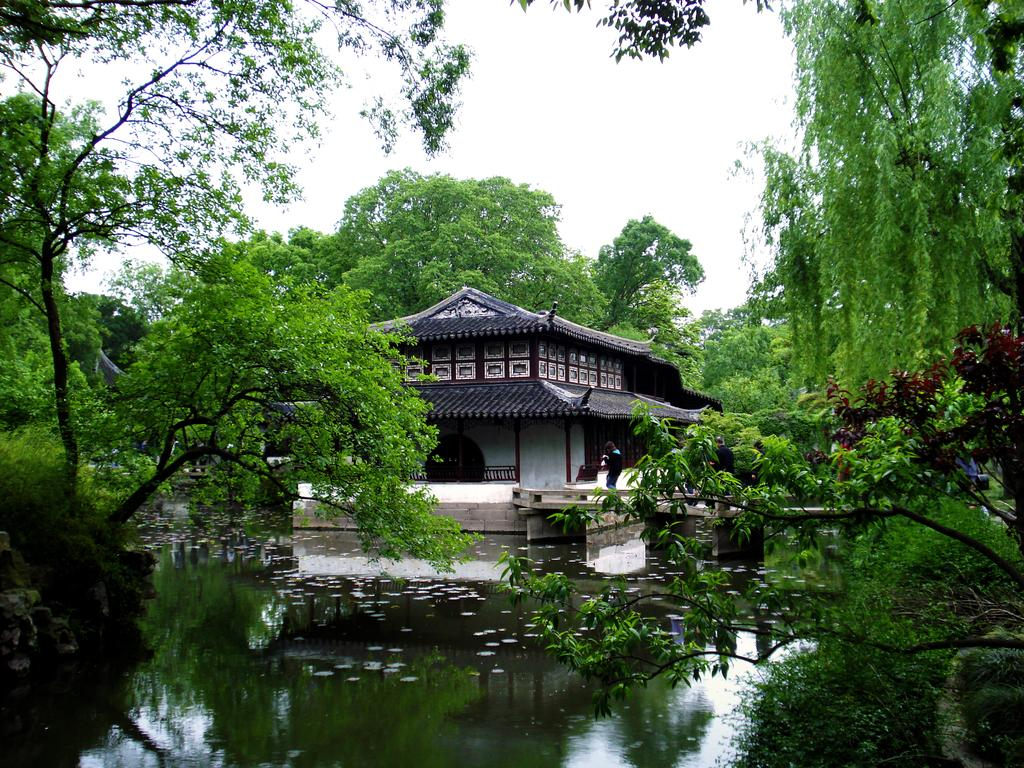What is the main feature of the image? There is water in the image. What structure is built on the water? There is a house on the water. Can you describe the person's location in the image? There is a person standing near the house. What type of vegetation can be seen around the water? Trees are visible around the water. What is visible at the top of the image? The sky is visible at the top of the image. How many bushes are floating on the water in the image? There are no bushes visible in the image; only water, a house, a person, trees, and the sky can be seen. What type of star can be seen shining brightly in the image? There is no star visible in the image; only the sky is visible at the top of the image. 